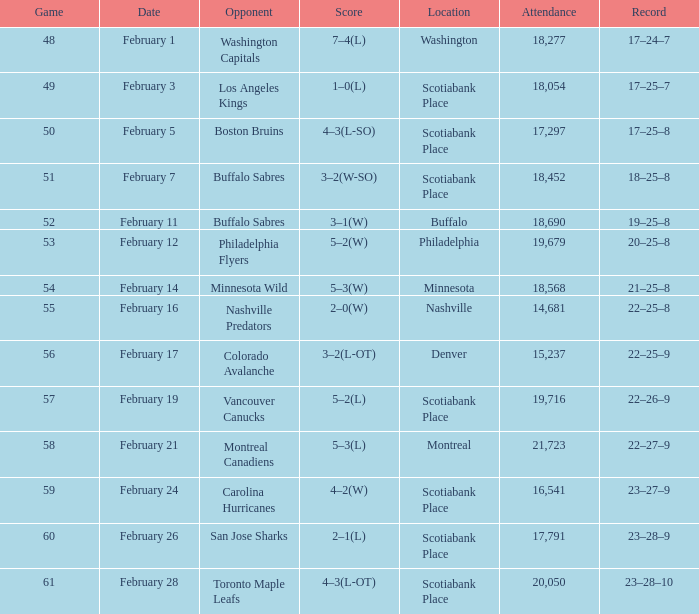What average game was held on february 24 and has an attendance smaller than 16,541? None. 